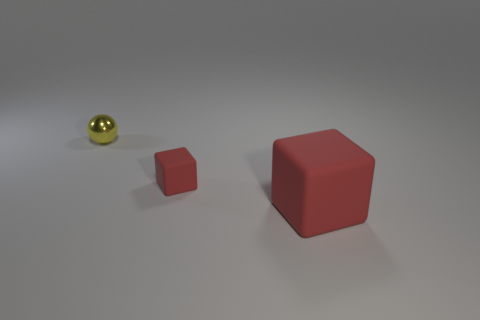What is the shape of the red rubber thing that is the same size as the metal object? The shape of the red rubber object that is the same size as the metal object is a cube. It has six faces, all of which are squares, and every angle is a right angle, giving it its distinctive box-like shape. 